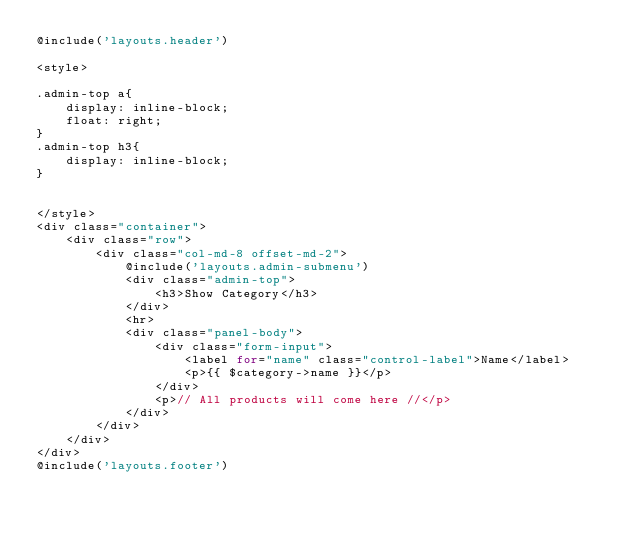Convert code to text. <code><loc_0><loc_0><loc_500><loc_500><_PHP_>@include('layouts.header')

<style>

.admin-top a{
    display: inline-block;
    float: right;
}
.admin-top h3{
    display: inline-block;
}


</style>
<div class="container">    
    <div class="row">
        <div class="col-md-8 offset-md-2">
            @include('layouts.admin-submenu')
            <div class="admin-top">
                <h3>Show Category</h3>
            </div>
            <hr>
            <div class="panel-body">
                <div class="form-input">
                    <label for="name" class="control-label">Name</label>
                    <p>{{ $category->name }}</p>
                </div>
                <p>// All products will come here //</p>
            </div>
        </div>
    </div>
</div>
@include('layouts.footer')</code> 